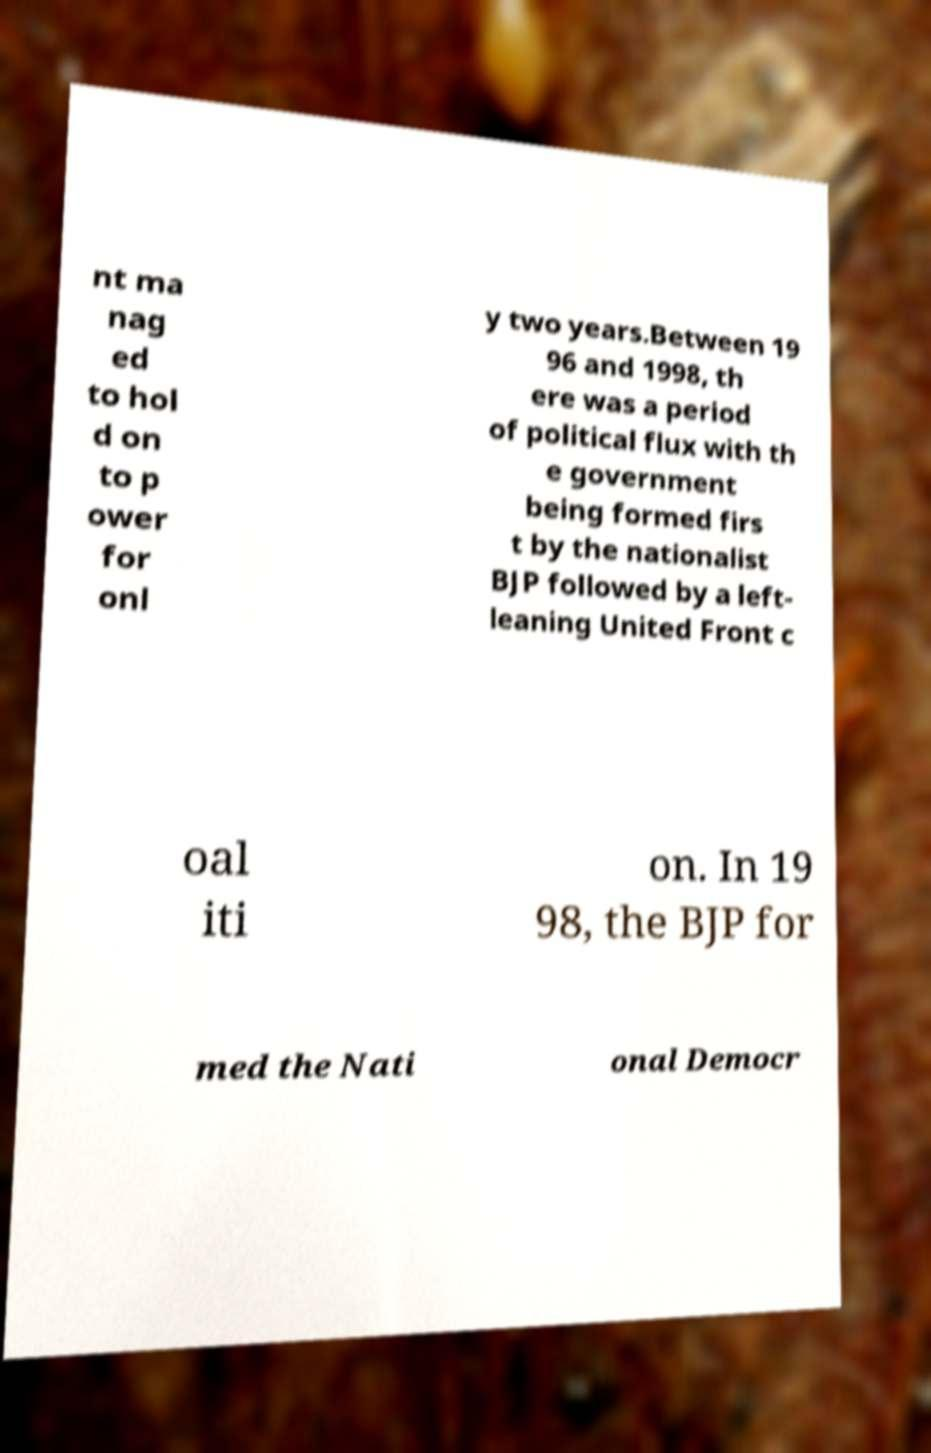I need the written content from this picture converted into text. Can you do that? nt ma nag ed to hol d on to p ower for onl y two years.Between 19 96 and 1998, th ere was a period of political flux with th e government being formed firs t by the nationalist BJP followed by a left- leaning United Front c oal iti on. In 19 98, the BJP for med the Nati onal Democr 